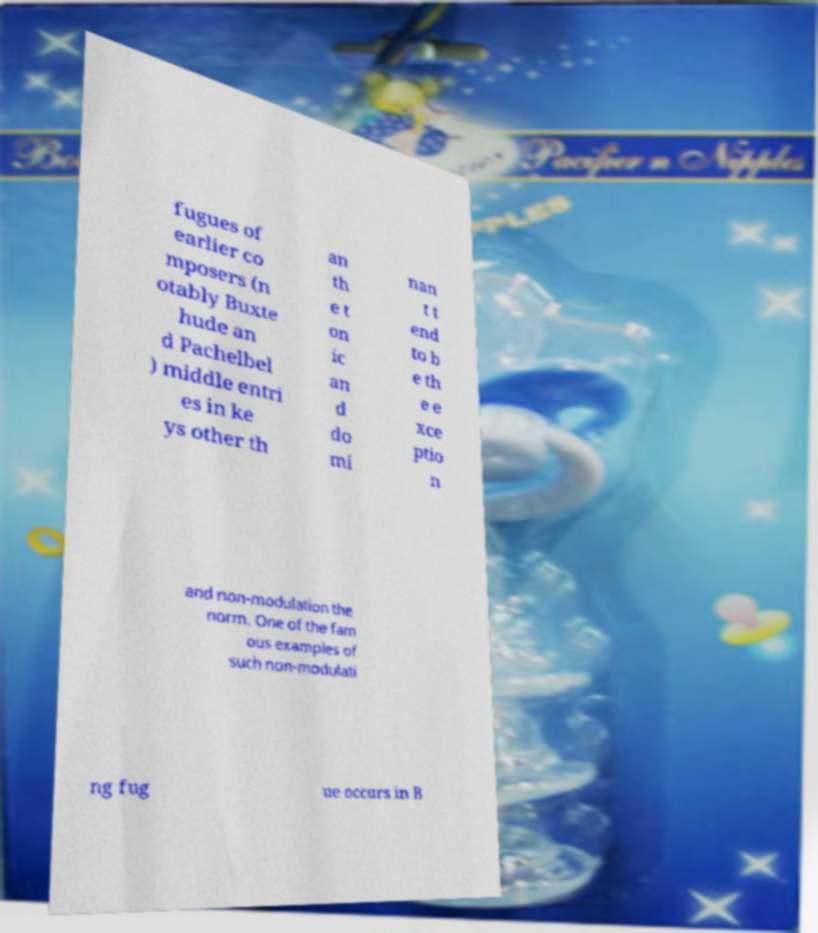I need the written content from this picture converted into text. Can you do that? fugues of earlier co mposers (n otably Buxte hude an d Pachelbel ) middle entri es in ke ys other th an th e t on ic an d do mi nan t t end to b e th e e xce ptio n and non-modulation the norm. One of the fam ous examples of such non-modulati ng fug ue occurs in B 